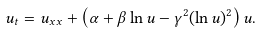Convert formula to latex. <formula><loc_0><loc_0><loc_500><loc_500>u _ { t } = u _ { x x } + \left ( \alpha + \beta \ln u - \gamma ^ { 2 } ( \ln u ) ^ { 2 } \right ) u .</formula> 